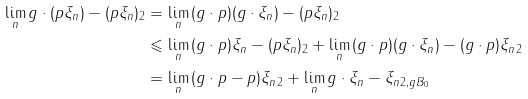<formula> <loc_0><loc_0><loc_500><loc_500>\lim _ { n } \| g \cdot ( p \xi _ { n } ) - ( p \xi _ { n } ) \| _ { 2 } & = \lim _ { n } \| ( g \cdot p ) ( g \cdot \xi _ { n } ) - ( p \xi _ { n } ) \| _ { 2 } \\ & \leqslant \lim _ { n } \| ( g \cdot p ) \xi _ { n } - ( p \xi _ { n } ) \| _ { 2 } + \lim _ { n } \| ( g \cdot p ) ( g \cdot \xi _ { n } ) - ( g \cdot p ) \xi _ { n } \| _ { 2 } \\ & = \lim _ { n } \| ( g \cdot p - p ) \xi _ { n } \| _ { 2 } + \lim _ { n } \| g \cdot \xi _ { n } - \xi _ { n } \| _ { 2 , g B _ { 0 } }</formula> 